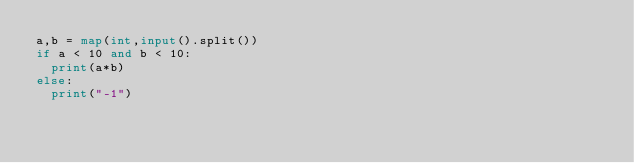Convert code to text. <code><loc_0><loc_0><loc_500><loc_500><_Python_>a,b = map(int,input().split())
if a < 10 and b < 10:
  print(a*b)
else:
  print("-1")</code> 